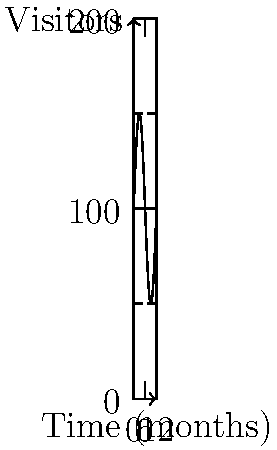The graph shows the number of visitors to a public library over a 12-month period. The function $f(t) = 100 + 50\sin(\frac{\pi t}{6})$ represents the number of visitors (in hundreds) at time $t$ (in months). At what time during the first 6 months is the rate of change in visitors the highest? What is this maximum rate of change? To solve this problem, we need to follow these steps:

1) The rate of change is given by the derivative of the function. Let's find $f'(t)$:
   
   $f'(t) = 50 \cdot \frac{\pi}{6} \cos(\frac{\pi t}{6})$

2) The maximum rate of change will occur when $f'(t)$ is at its maximum value. For cosine functions, this occurs when the argument is a multiple of $2\pi$, i.e., when $\cos(\frac{\pi t}{6}) = 1$.

3) In the first 6 months, this happens when $\frac{\pi t}{6} = 0$, or when $t = 0$.

4) To find the maximum rate of change, we evaluate $f'(0)$:
   
   $f'(0) = 50 \cdot \frac{\pi}{6} \cos(0) = 50 \cdot \frac{\pi}{6} \approx 26.18$

5) This means the maximum rate of change is about 26.18 hundred, or 2,618 visitors per month.

Therefore, the rate of change in visitors is highest at the beginning of the period (t = 0 months), and the maximum rate of change is approximately 2,618 visitors per month.
Answer: Time: 0 months; Maximum rate: 2,618 visitors/month 